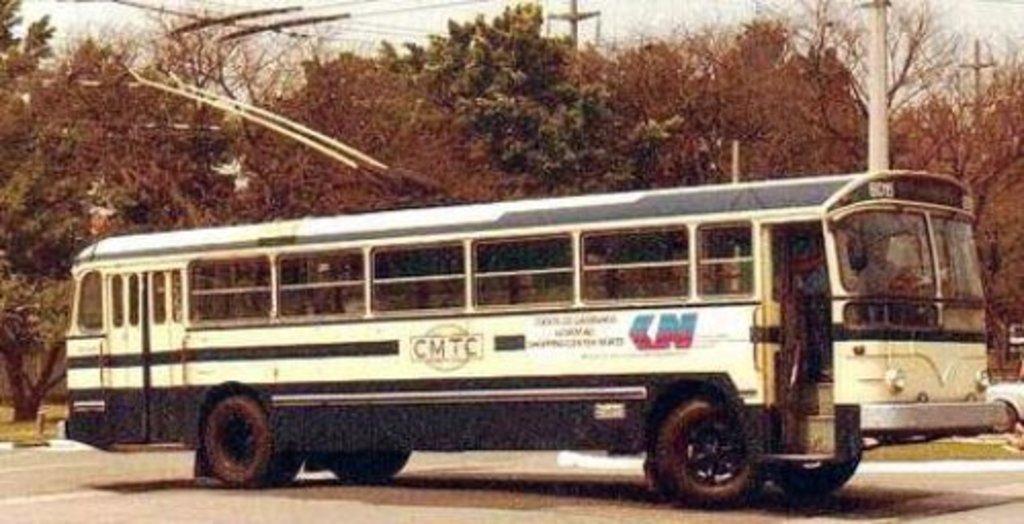Can you describe this image briefly? In this image there is a bus on the road. In the background there are trees. On the right side there is a pole. At the top there are wires. On the right side bottom there is a car in the background. 